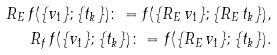Convert formula to latex. <formula><loc_0><loc_0><loc_500><loc_500>R _ { E } \, f ( \{ v _ { 1 } \} ; \{ t _ { k } \} ) \colon = f ( \{ R _ { E } \, v _ { 1 } \} ; \{ R _ { E } \, t _ { k } \} ) , \\ R _ { f } \, f ( \{ v _ { 1 } \} ; \{ t _ { k } \} ) \colon = f ( \{ R _ { E } \, v _ { 1 } \} ; \{ t _ { k } \} ) .</formula> 